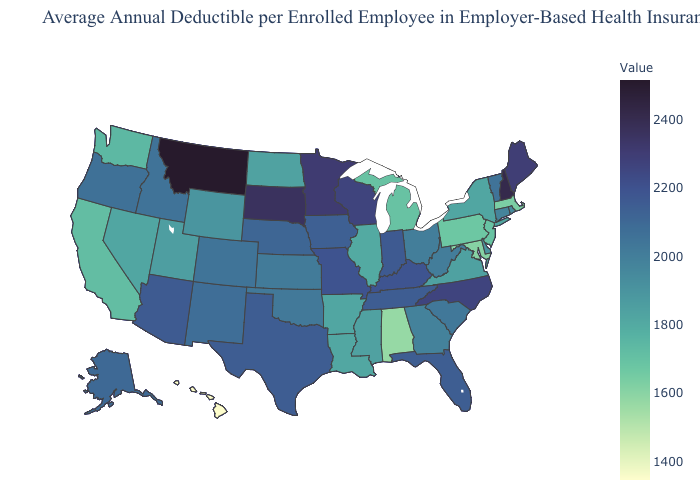Does New Jersey have the highest value in the USA?
Answer briefly. No. Does Connecticut have a lower value than Pennsylvania?
Be succinct. No. Does Arizona have a higher value than Maine?
Concise answer only. No. Does Kansas have a lower value than Indiana?
Answer briefly. Yes. Which states hav the highest value in the Northeast?
Quick response, please. New Hampshire. Does the map have missing data?
Concise answer only. No. Among the states that border New Hampshire , which have the highest value?
Short answer required. Maine. 